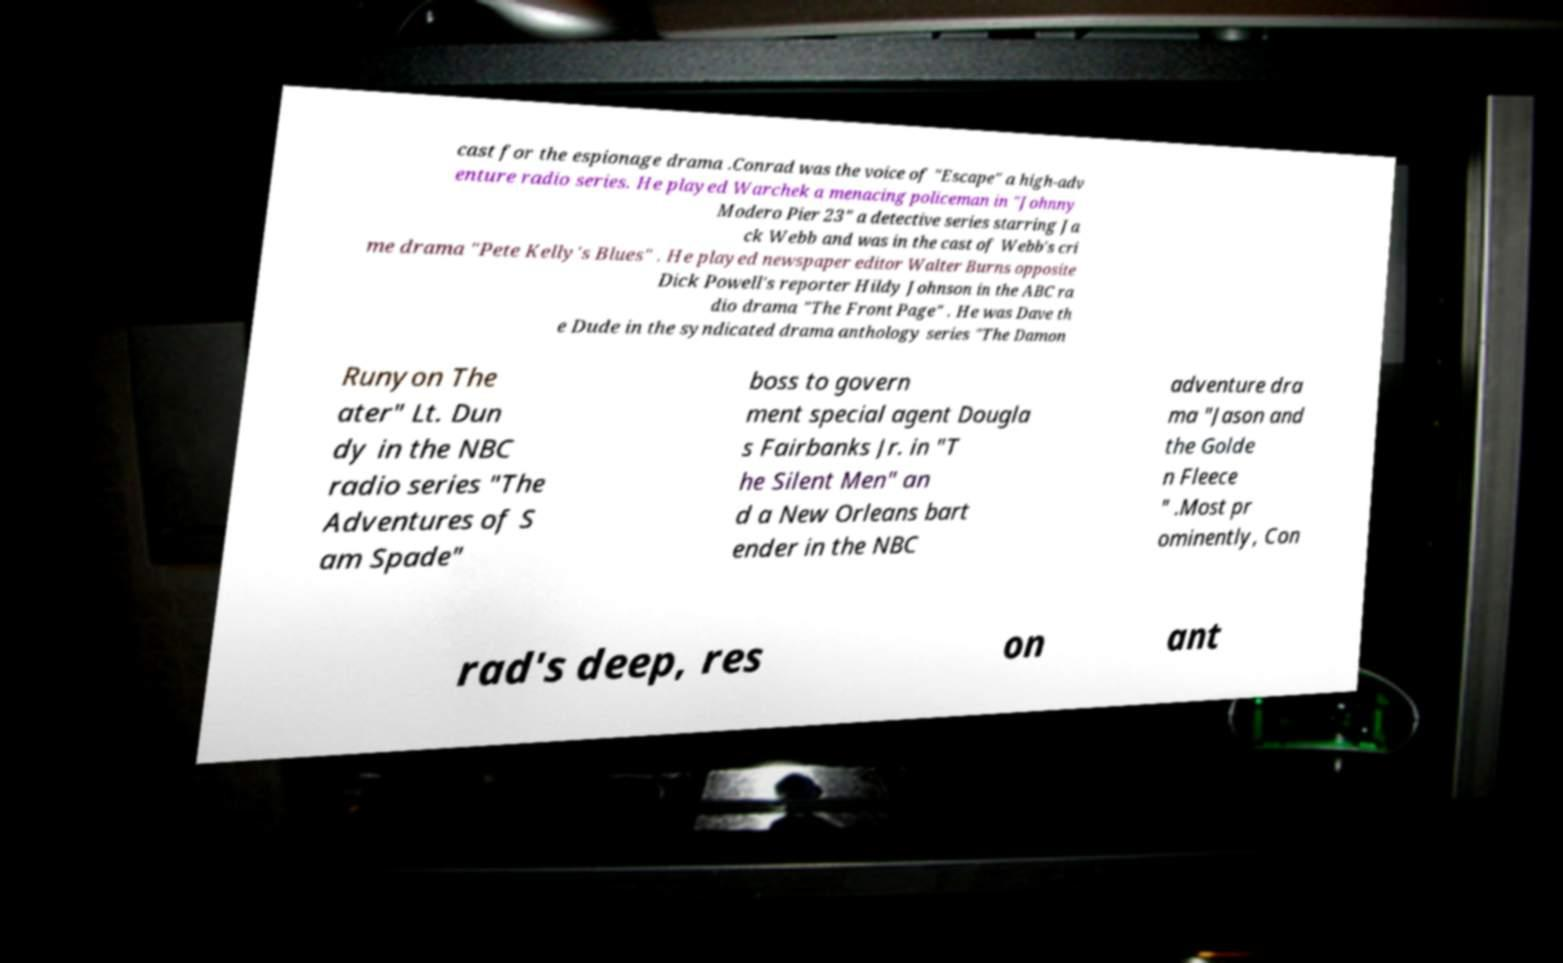Can you read and provide the text displayed in the image?This photo seems to have some interesting text. Can you extract and type it out for me? cast for the espionage drama .Conrad was the voice of "Escape" a high-adv enture radio series. He played Warchek a menacing policeman in "Johnny Modero Pier 23" a detective series starring Ja ck Webb and was in the cast of Webb's cri me drama "Pete Kelly's Blues" . He played newspaper editor Walter Burns opposite Dick Powell's reporter Hildy Johnson in the ABC ra dio drama "The Front Page" . He was Dave th e Dude in the syndicated drama anthology series "The Damon Runyon The ater" Lt. Dun dy in the NBC radio series "The Adventures of S am Spade" boss to govern ment special agent Dougla s Fairbanks Jr. in "T he Silent Men" an d a New Orleans bart ender in the NBC adventure dra ma "Jason and the Golde n Fleece " .Most pr ominently, Con rad's deep, res on ant 